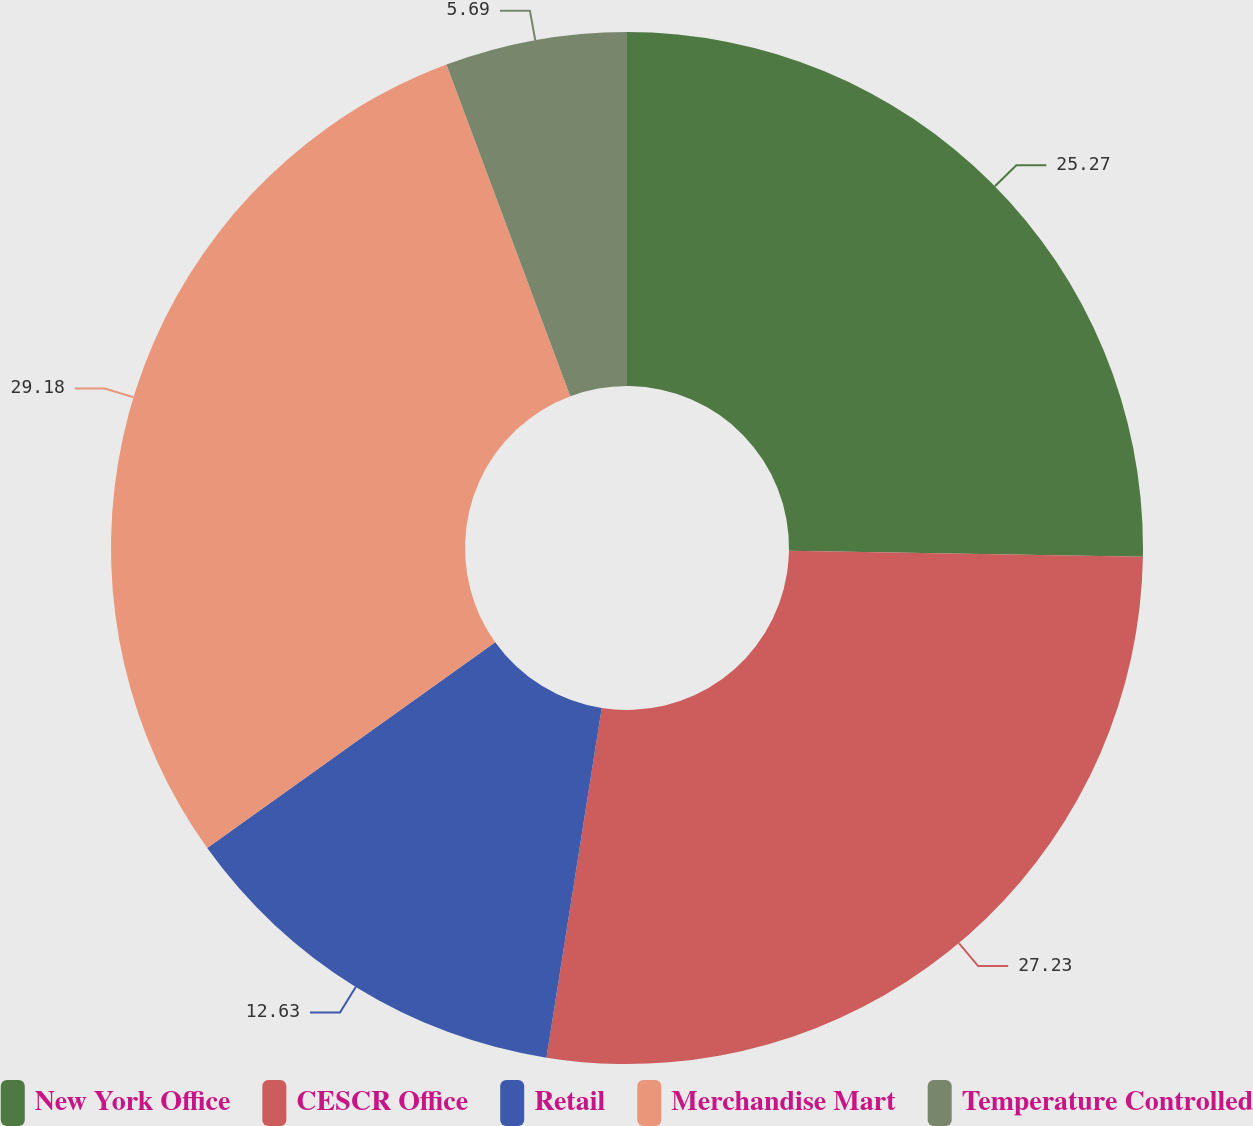Convert chart. <chart><loc_0><loc_0><loc_500><loc_500><pie_chart><fcel>New York Office<fcel>CESCR Office<fcel>Retail<fcel>Merchandise Mart<fcel>Temperature Controlled<nl><fcel>25.27%<fcel>27.23%<fcel>12.63%<fcel>29.19%<fcel>5.69%<nl></chart> 